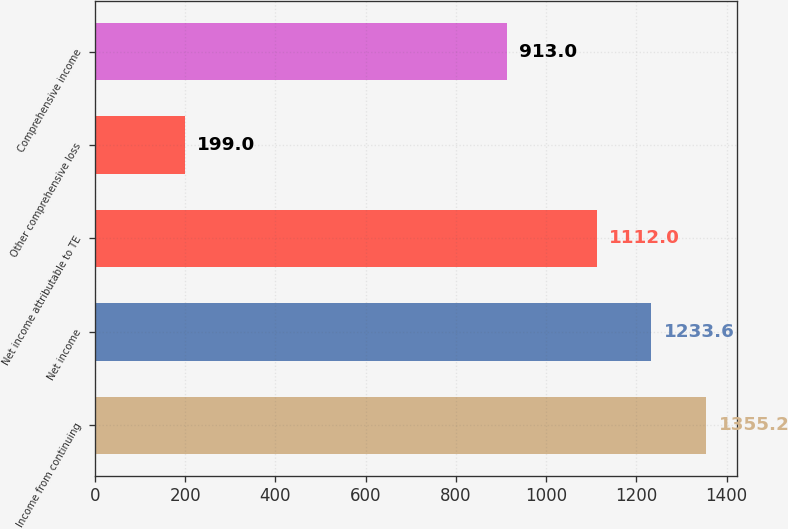Convert chart. <chart><loc_0><loc_0><loc_500><loc_500><bar_chart><fcel>Income from continuing<fcel>Net income<fcel>Net income attributable to TE<fcel>Other comprehensive loss<fcel>Comprehensive income<nl><fcel>1355.2<fcel>1233.6<fcel>1112<fcel>199<fcel>913<nl></chart> 